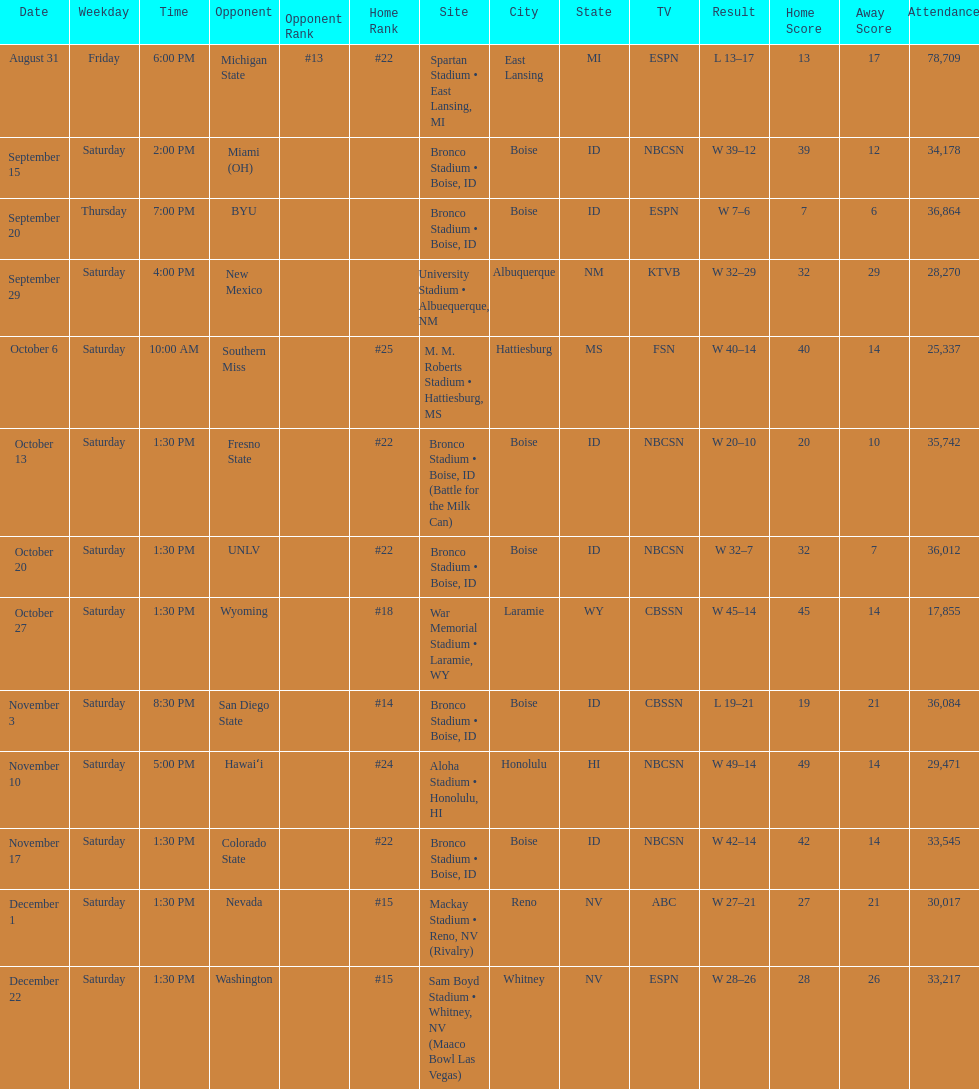Number of points scored by miami (oh) against the broncos. 12. 